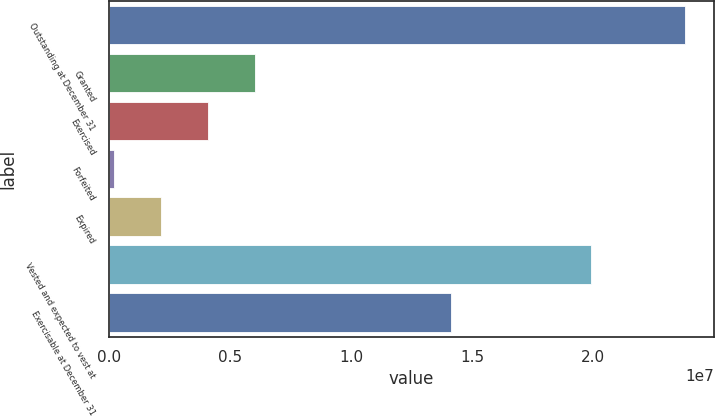<chart> <loc_0><loc_0><loc_500><loc_500><bar_chart><fcel>Outstanding at December 31<fcel>Granted<fcel>Exercised<fcel>Forfeited<fcel>Expired<fcel>Vested and expected to vest at<fcel>Exercisable at December 31<nl><fcel>2.37858e+07<fcel>5.99563e+06<fcel>4.0611e+06<fcel>192056<fcel>2.12658e+06<fcel>1.99167e+07<fcel>1.41131e+07<nl></chart> 